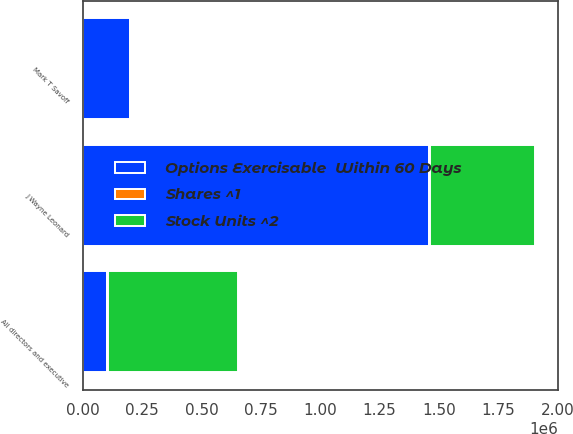<chart> <loc_0><loc_0><loc_500><loc_500><stacked_bar_chart><ecel><fcel>J Wayne Leonard<fcel>Mark T Savoff<fcel>All directors and executive<nl><fcel>Stock Units ^2<fcel>444898<fcel>4363<fcel>549077<nl><fcel>Options Exercisable  Within 60 Days<fcel>1.45853e+06<fcel>199467<fcel>101915<nl><fcel>Shares ^1<fcel>3111<fcel>263<fcel>3374<nl></chart> 